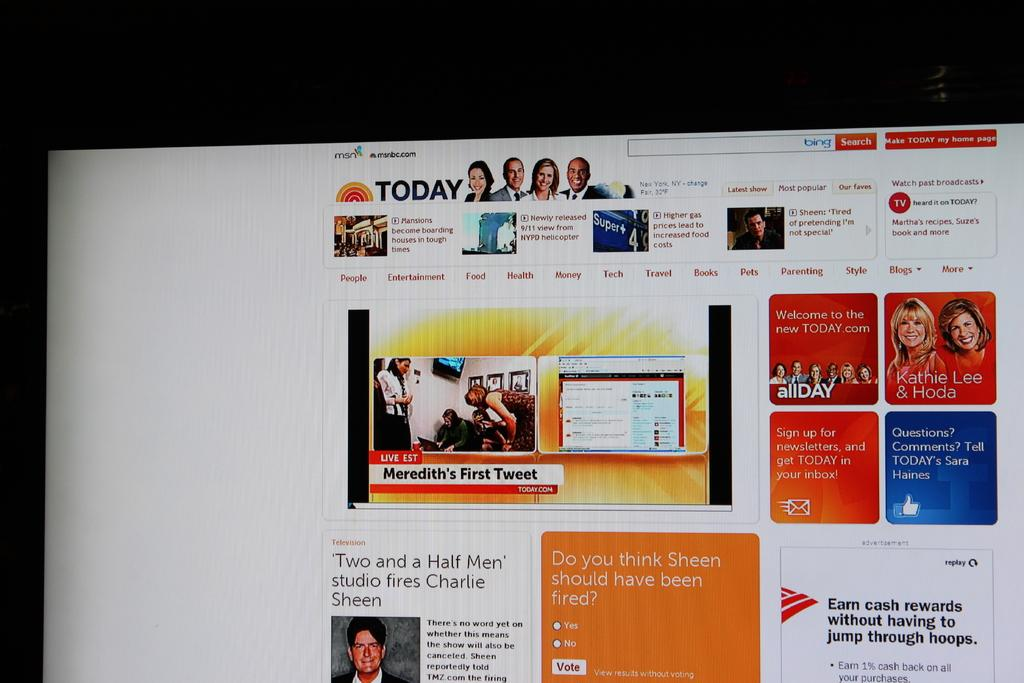What is the main subject of the image? The main subject of the image appears to be a screen. What can be seen on the screen? There are many advertisements on the screen. How many kittens are playing with clocks in the image? There are no kittens or clocks present in the image. What type of alarm can be heard in the image? There is no alarm present in the image, as it is a static image and not a video or audio recording. 